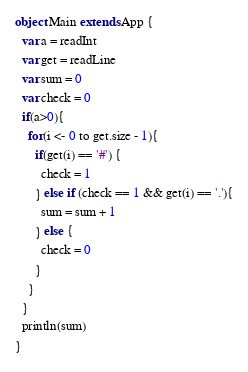Convert code to text. <code><loc_0><loc_0><loc_500><loc_500><_Scala_>object Main extends App {
  var a = readInt
  var get = readLine
  var sum = 0
  var check = 0
  if(a>0){
    for(i <- 0 to get.size - 1){
      if(get(i) == '#') {
        check = 1
      } else if (check == 1 && get(i) == '.'){
        sum = sum + 1
      } else {
        check = 0
      }
    }
  }
  println(sum)
}</code> 